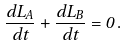<formula> <loc_0><loc_0><loc_500><loc_500>\frac { d L _ { A } } { d t } + \frac { d L _ { B } } { d t } = 0 \, .</formula> 